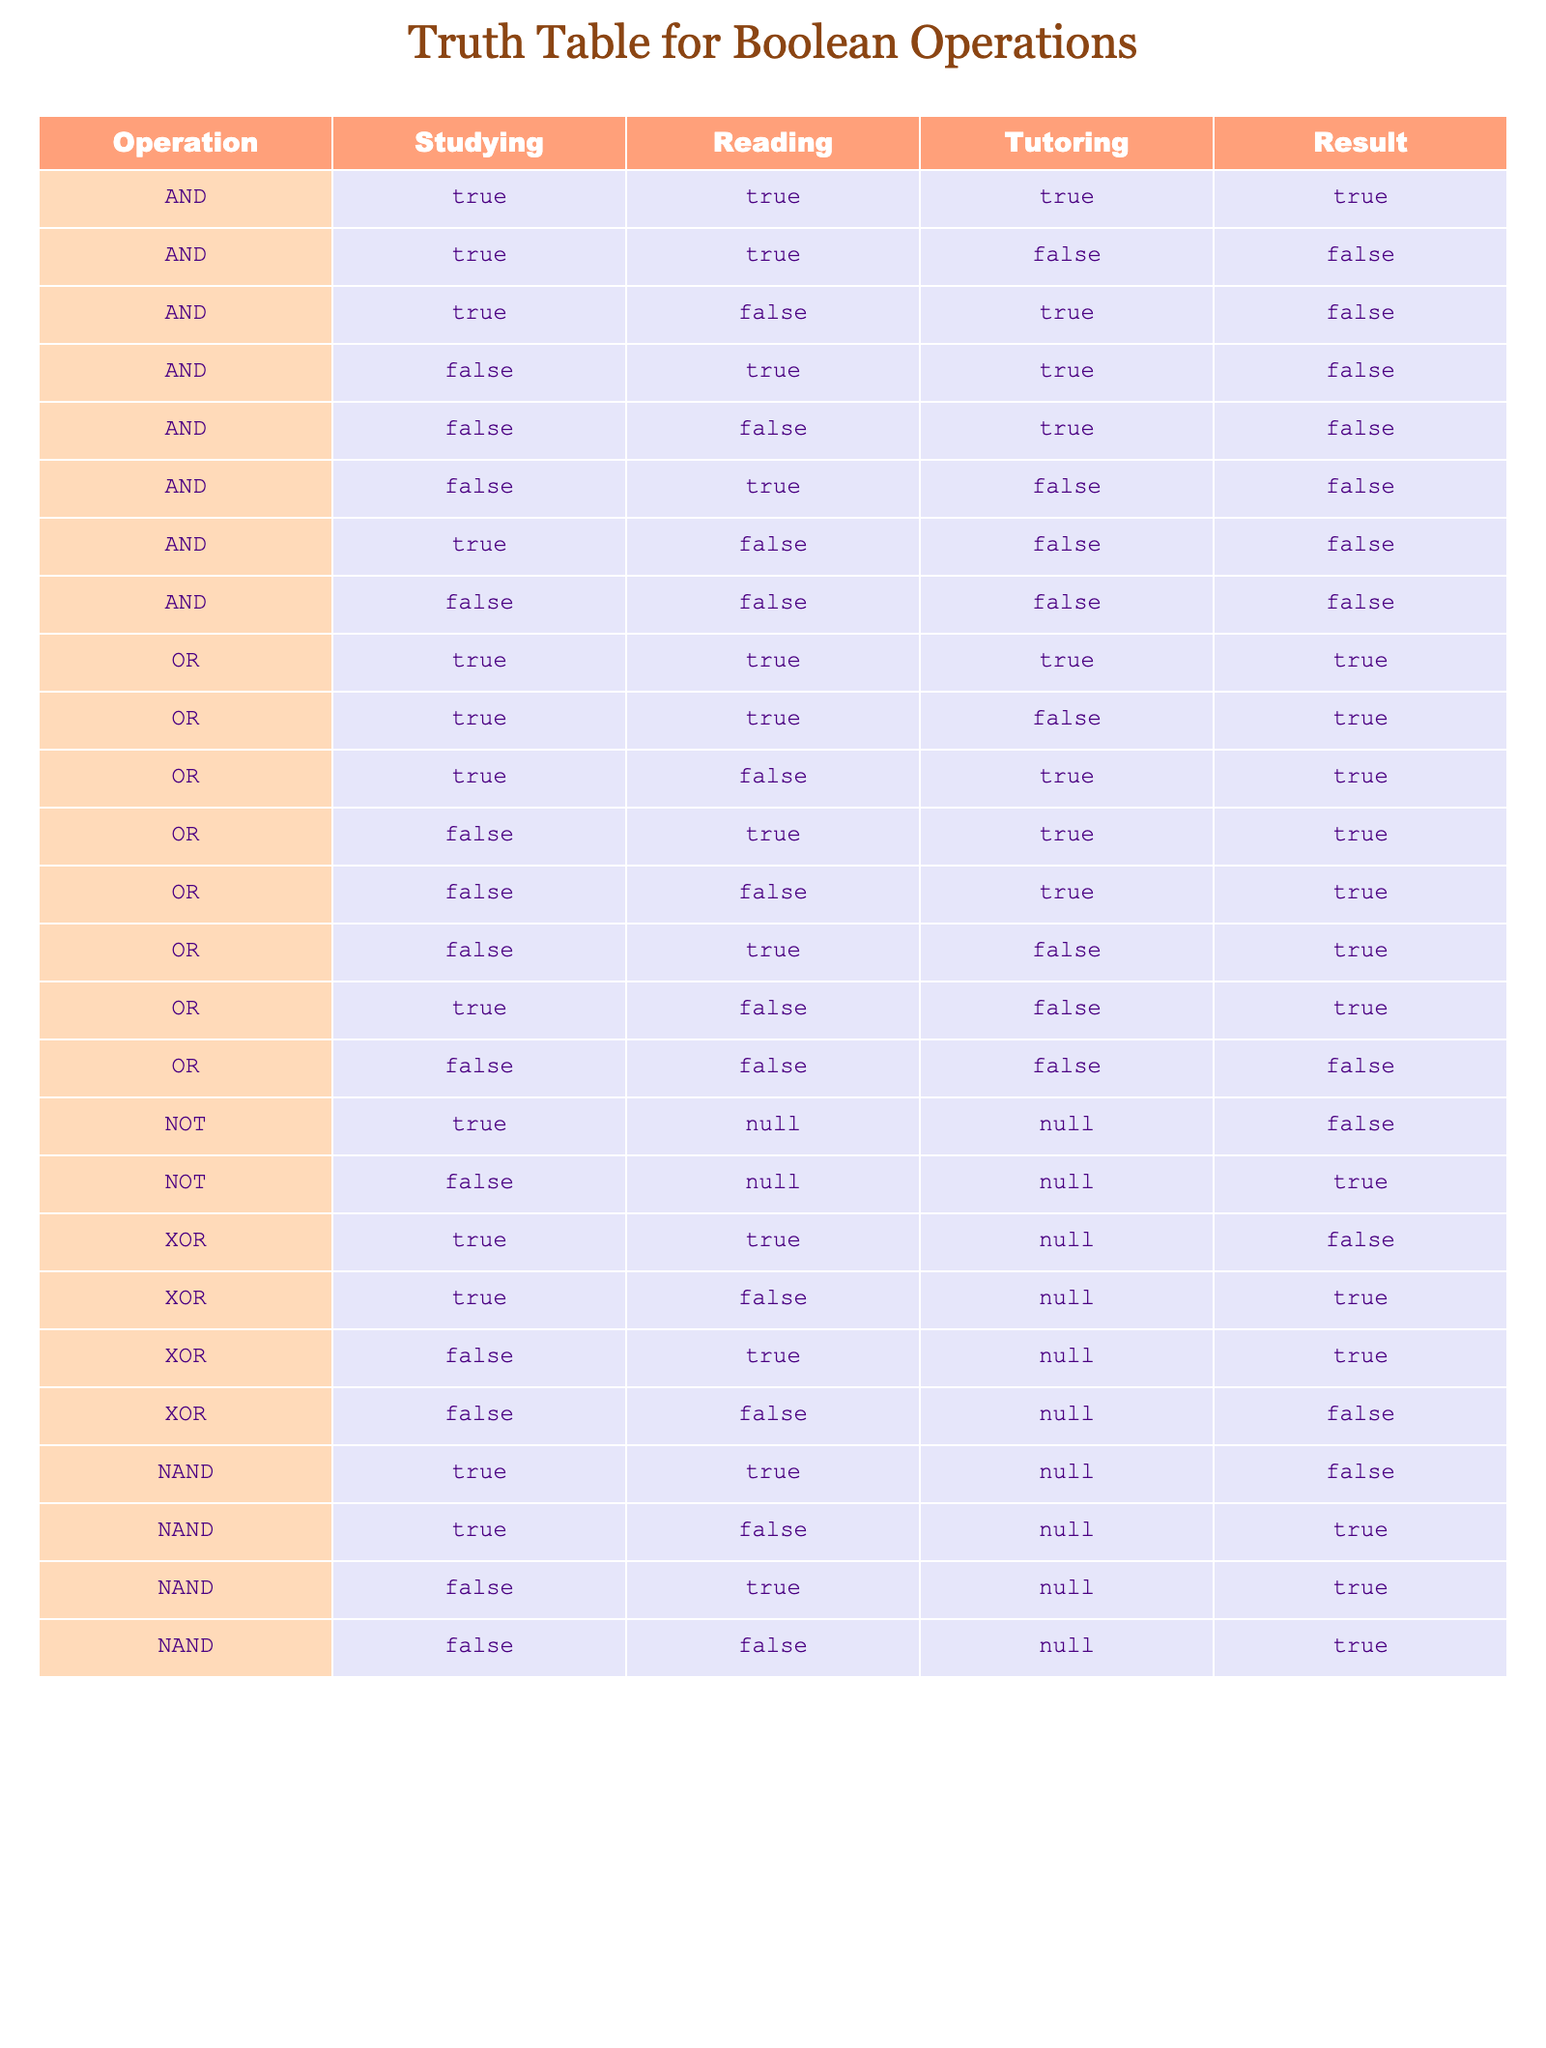What is the result of the AND operation when studying is true and tutoring is false? In the AND operation, both study and tutoring need to be true for the result to be true. Here, studying is true, but tutoring is false, which results in false.
Answer: False What are the results of the OR operation when studying is false and reading is true? In the OR operation, if either of the values is true, the result is true. Here, studying is false and reading is true, making the overall result true.
Answer: True How many true outcomes are there for the XOR operation? The XOR operation is true when one of the inputs is true and the other is false. Analyzing the entries, when studying is true and reading is false or vice versa gives two true outcomes out of four.
Answer: 2 Is the result of the NAND operation true when both studying and reading are true? The NAND operation is the opposite of AND; it is false only when both inputs are true. Here, since both studying and reading are true, the result is false.
Answer: No What is the combined result of the OR operation when studying is true and tutoring is false? In the OR operation, only one true value is needed for the result to be true. Here, studying is true, making the outcome true regardless of the other inputs.
Answer: True What is the result of the NOT operation when the input is false? The NOT operation inverts the input; thus, the result will be true if the input is false. Therefore, the output of NOT with a false input is true.
Answer: True In how many cases does the AND operation yield true? The AND operation yields true only when all inputs are true. In the table, there is only one case where all inputs (studying, reading, tutoring) are true.
Answer: 1 When is the result of the NAND operation true? The NAND operation produces a true result in every case except when all inputs are true. By evaluating the table, this means it will be true for all combinations apart from the case where both studying and reading are true.
Answer: 3 